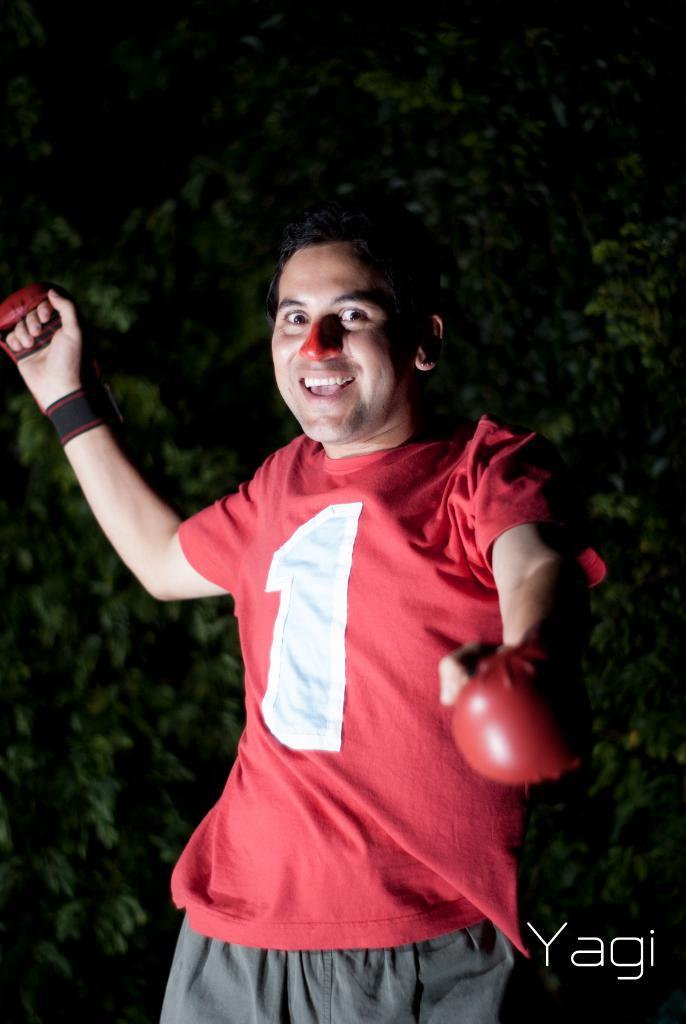What is the main subject of the image? The main subject of the image is a man standing. What is the man wearing in the image? The man is wearing clothes and boxing gloves. Are there any additional elements in the image besides the man? Yes, there is a watermark and leaves present in the image. What type of cherries can be seen growing on the man's boxing gloves in the image? There are no cherries present in the image, and the man's boxing gloves are not associated with any fruit. 